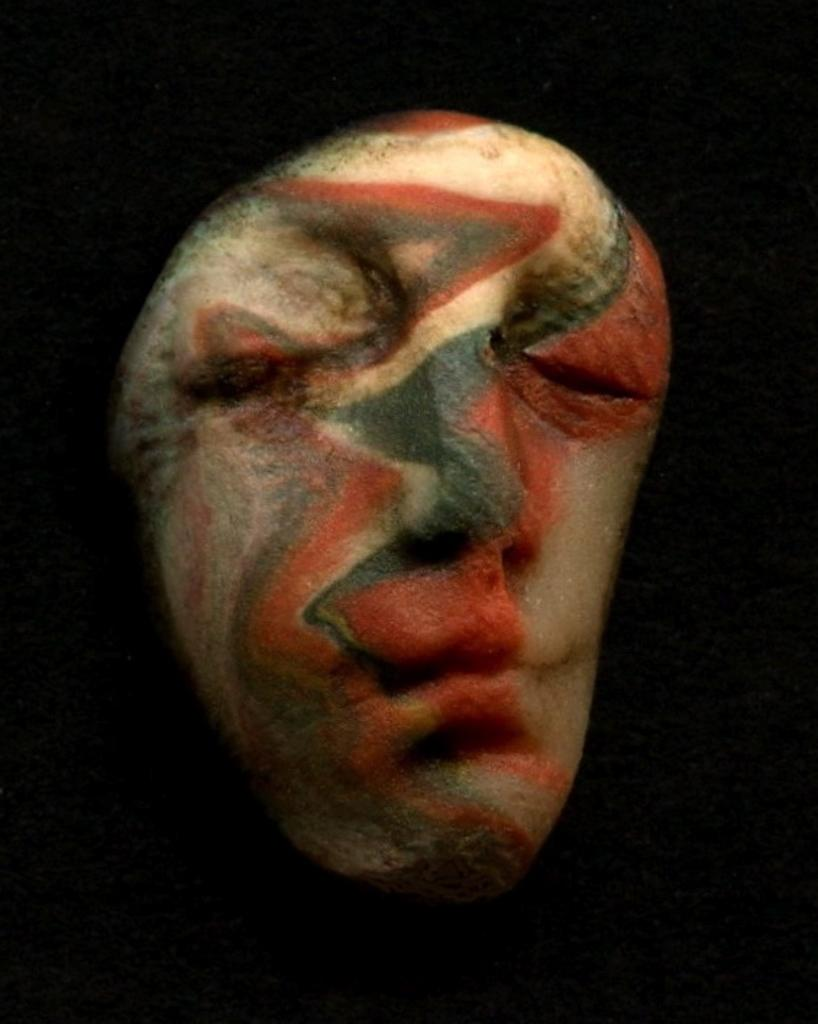What is the main subject of the image? The main subject of the image is a tattoo of a person's face. What can be observed about the background of the image? The background of the image is dark. What type of kite is being flown in the image? There is no kite present in the image; it features a tattoo of a person's face with a dark background. 